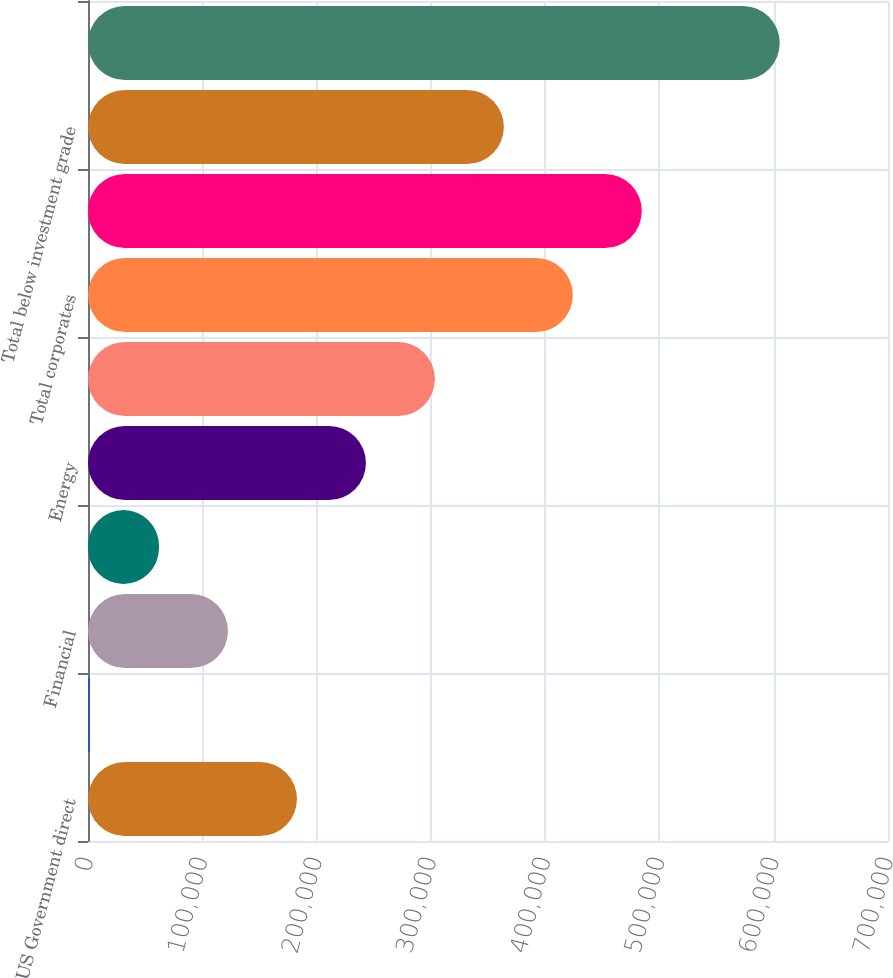Convert chart to OTSL. <chart><loc_0><loc_0><loc_500><loc_500><bar_chart><fcel>US Government direct<fcel>States municipalities and<fcel>Financial<fcel>Utilities<fcel>Energy<fcel>Other corporate sectors<fcel>Total corporates<fcel>Total investment grade<fcel>Total below investment grade<fcel>Total fixed maturities<nl><fcel>182826<fcel>1771<fcel>122474<fcel>62122.7<fcel>243178<fcel>303530<fcel>424233<fcel>484585<fcel>363881<fcel>605288<nl></chart> 